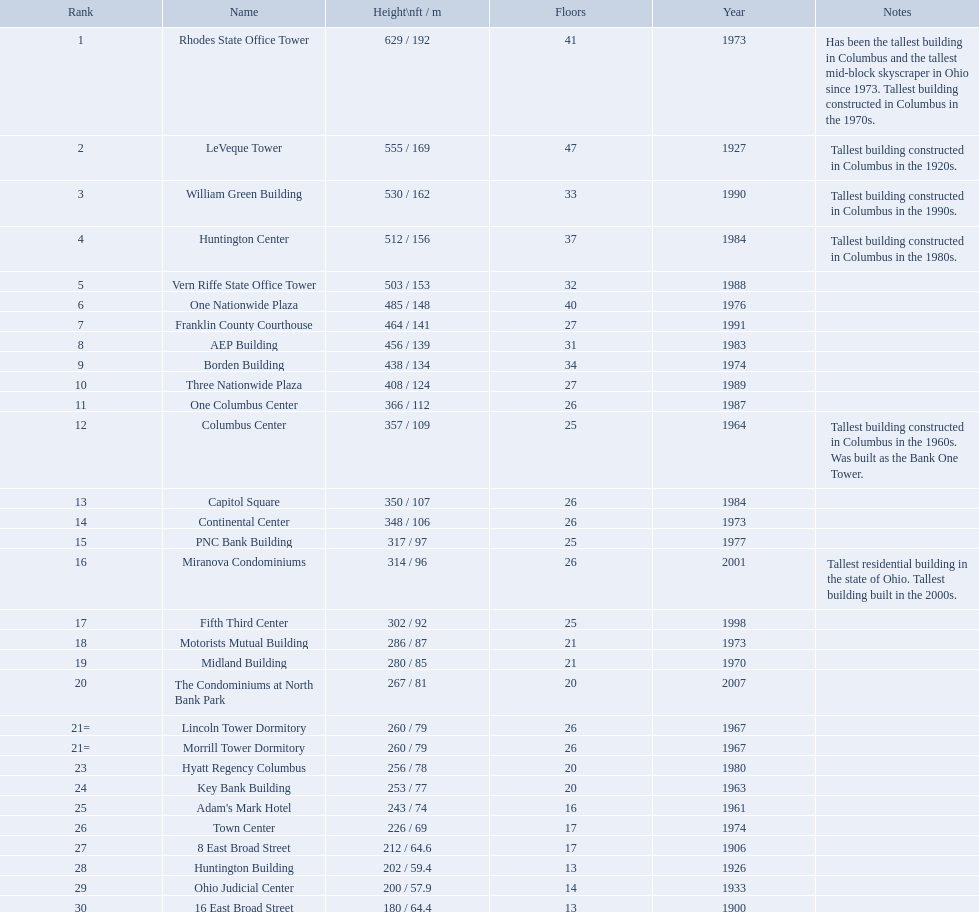How tall is the aep building? 456 / 139. How tall is the one columbus center? 366 / 112. Of these two buildings, which is taller? AEP Building. What is the altitude of the aep building? 456 / 139. What is the altitude of the one columbus center? 366 / 112. Among these two edifices, which one is taller? AEP Building. Can you give me this table as a dict? {'header': ['Rank', 'Name', 'Height\\nft / m', 'Floors', 'Year', 'Notes'], 'rows': [['1', 'Rhodes State Office Tower', '629 / 192', '41', '1973', 'Has been the tallest building in Columbus and the tallest mid-block skyscraper in Ohio since 1973. Tallest building constructed in Columbus in the 1970s.'], ['2', 'LeVeque Tower', '555 / 169', '47', '1927', 'Tallest building constructed in Columbus in the 1920s.'], ['3', 'William Green Building', '530 / 162', '33', '1990', 'Tallest building constructed in Columbus in the 1990s.'], ['4', 'Huntington Center', '512 / 156', '37', '1984', 'Tallest building constructed in Columbus in the 1980s.'], ['5', 'Vern Riffe State Office Tower', '503 / 153', '32', '1988', ''], ['6', 'One Nationwide Plaza', '485 / 148', '40', '1976', ''], ['7', 'Franklin County Courthouse', '464 / 141', '27', '1991', ''], ['8', 'AEP Building', '456 / 139', '31', '1983', ''], ['9', 'Borden Building', '438 / 134', '34', '1974', ''], ['10', 'Three Nationwide Plaza', '408 / 124', '27', '1989', ''], ['11', 'One Columbus Center', '366 / 112', '26', '1987', ''], ['12', 'Columbus Center', '357 / 109', '25', '1964', 'Tallest building constructed in Columbus in the 1960s. Was built as the Bank One Tower.'], ['13', 'Capitol Square', '350 / 107', '26', '1984', ''], ['14', 'Continental Center', '348 / 106', '26', '1973', ''], ['15', 'PNC Bank Building', '317 / 97', '25', '1977', ''], ['16', 'Miranova Condominiums', '314 / 96', '26', '2001', 'Tallest residential building in the state of Ohio. Tallest building built in the 2000s.'], ['17', 'Fifth Third Center', '302 / 92', '25', '1998', ''], ['18', 'Motorists Mutual Building', '286 / 87', '21', '1973', ''], ['19', 'Midland Building', '280 / 85', '21', '1970', ''], ['20', 'The Condominiums at North Bank Park', '267 / 81', '20', '2007', ''], ['21=', 'Lincoln Tower Dormitory', '260 / 79', '26', '1967', ''], ['21=', 'Morrill Tower Dormitory', '260 / 79', '26', '1967', ''], ['23', 'Hyatt Regency Columbus', '256 / 78', '20', '1980', ''], ['24', 'Key Bank Building', '253 / 77', '20', '1963', ''], ['25', "Adam's Mark Hotel", '243 / 74', '16', '1961', ''], ['26', 'Town Center', '226 / 69', '17', '1974', ''], ['27', '8 East Broad Street', '212 / 64.6', '17', '1906', ''], ['28', 'Huntington Building', '202 / 59.4', '13', '1926', ''], ['29', 'Ohio Judicial Center', '200 / 57.9', '14', '1933', ''], ['30', '16 East Broad Street', '180 / 64.4', '13', '1900', '']]} Which of columbus, ohio's tallest structures were constructed during the 1980s? Huntington Center, Vern Riffe State Office Tower, AEP Building, Three Nationwide Plaza, One Columbus Center, Capitol Square, Hyatt Regency Columbus. Among them, which ones have 26 to 31 stories? AEP Building, Three Nationwide Plaza, One Columbus Center, Capitol Square. Out of these, which one is the tallest? AEP Building. In columbus, ohio, which tallest buildings were erected in the 1980s? Huntington Center, Vern Riffe State Office Tower, AEP Building, Three Nationwide Plaza, One Columbus Center, Capitol Square, Hyatt Regency Columbus. From this list, which buildings consist of 26 to 31 floors? AEP Building, Three Nationwide Plaza, One Columbus Center, Capitol Square. Among these, which building stands as the tallest? AEP Building. What is the height of the aep building? 456 / 139. What is the height of one columbus center? 366 / 112. Between these two structures, which one has a greater height? AEP Building. 